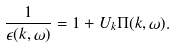<formula> <loc_0><loc_0><loc_500><loc_500>\frac { 1 } { \epsilon ( { k } , \omega ) } = 1 + U _ { k } \Pi ( { k } , \omega ) .</formula> 